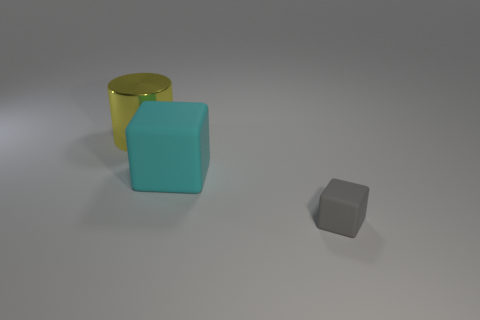Add 3 big yellow cylinders. How many objects exist? 6 Subtract all brown spheres. How many cyan blocks are left? 1 Subtract 0 brown cubes. How many objects are left? 3 Subtract all blocks. How many objects are left? 1 Subtract 2 blocks. How many blocks are left? 0 Subtract all gray cylinders. Subtract all purple spheres. How many cylinders are left? 1 Subtract all large shiny objects. Subtract all metal cubes. How many objects are left? 2 Add 1 big cyan things. How many big cyan things are left? 2 Add 1 yellow metallic cylinders. How many yellow metallic cylinders exist? 2 